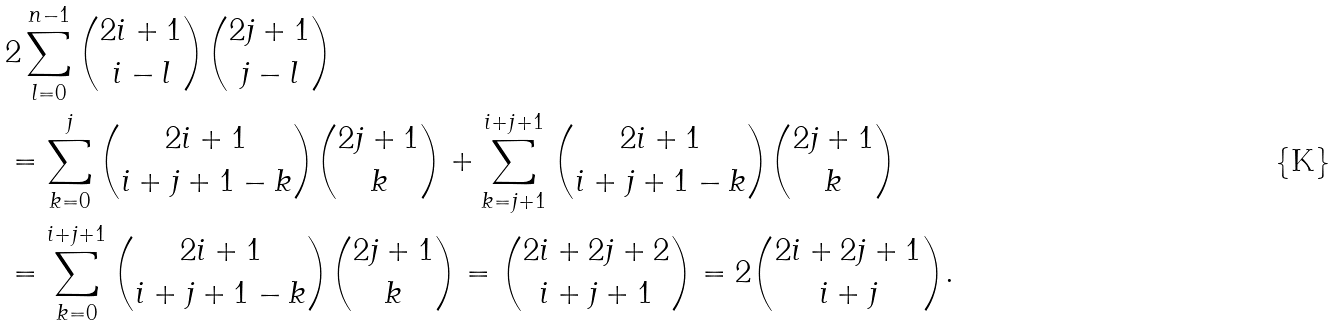<formula> <loc_0><loc_0><loc_500><loc_500>& 2 \sum _ { l = 0 } ^ { n - 1 } { 2 i + 1 \choose i - l } { 2 j + 1 \choose j - l } \\ & = \sum _ { k = 0 } ^ { j } { 2 i + 1 \choose i + j + 1 - k } { 2 j + 1 \choose k } + \sum _ { k = j + 1 } ^ { i + j + 1 } { 2 i + 1 \choose i + j + 1 - k } { 2 j + 1 \choose k } \\ & = \sum _ { k = 0 } ^ { i + j + 1 } { 2 i + 1 \choose i + j + 1 - k } { 2 j + 1 \choose k } = { 2 i + 2 j + 2 \choose i + j + 1 } = 2 { 2 i + 2 j + 1 \choose i + j } .</formula> 